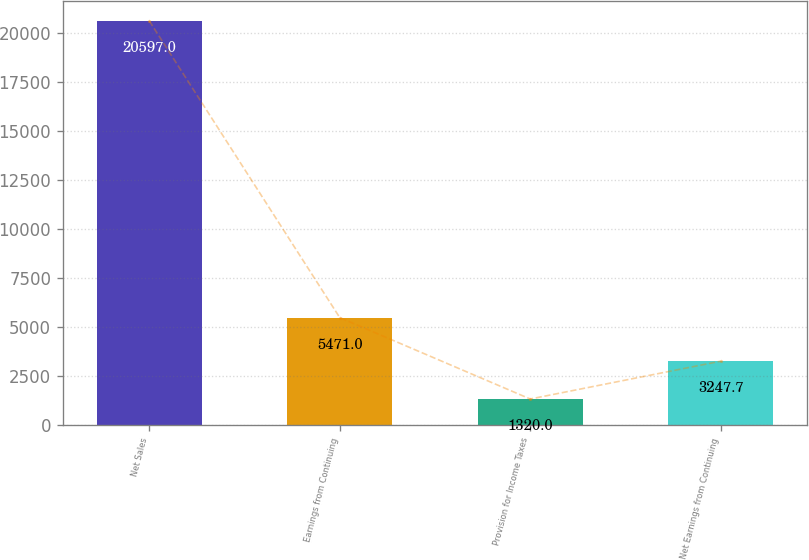<chart> <loc_0><loc_0><loc_500><loc_500><bar_chart><fcel>Net Sales<fcel>Earnings from Continuing<fcel>Provision for Income Taxes<fcel>Net Earnings from Continuing<nl><fcel>20597<fcel>5471<fcel>1320<fcel>3247.7<nl></chart> 